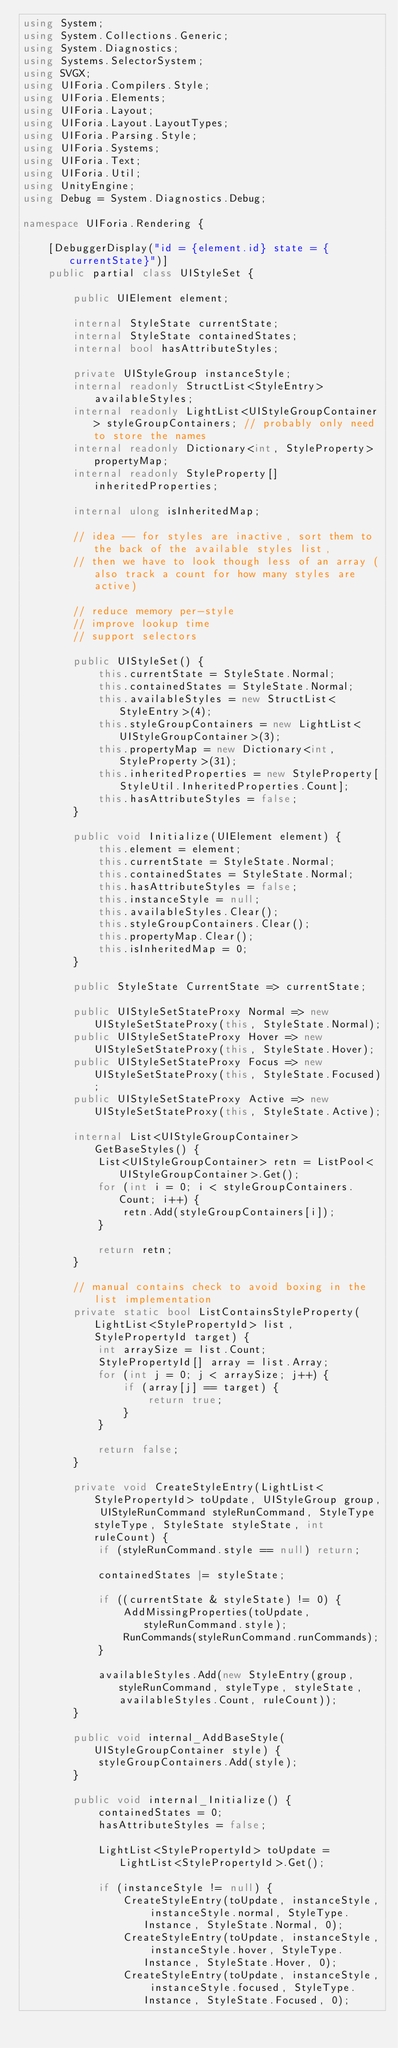<code> <loc_0><loc_0><loc_500><loc_500><_C#_>using System;
using System.Collections.Generic;
using System.Diagnostics;
using Systems.SelectorSystem;
using SVGX;
using UIForia.Compilers.Style;
using UIForia.Elements;
using UIForia.Layout;
using UIForia.Layout.LayoutTypes;
using UIForia.Parsing.Style;
using UIForia.Systems;
using UIForia.Text;
using UIForia.Util;
using UnityEngine;
using Debug = System.Diagnostics.Debug;

namespace UIForia.Rendering {

    [DebuggerDisplay("id = {element.id} state = {currentState}")]
    public partial class UIStyleSet {

        public UIElement element;

        internal StyleState currentState;
        internal StyleState containedStates;
        internal bool hasAttributeStyles;

        private UIStyleGroup instanceStyle;
        internal readonly StructList<StyleEntry> availableStyles;
        internal readonly LightList<UIStyleGroupContainer> styleGroupContainers; // probably only need to store the names
        internal readonly Dictionary<int, StyleProperty> propertyMap;
        internal readonly StyleProperty[] inheritedProperties;

        internal ulong isInheritedMap;

        // idea -- for styles are inactive, sort them to the back of the available styles list,
        // then we have to look though less of an array (also track a count for how many styles are active)

        // reduce memory per-style
        // improve lookup time
        // support selectors

        public UIStyleSet() {
            this.currentState = StyleState.Normal;
            this.containedStates = StyleState.Normal;
            this.availableStyles = new StructList<StyleEntry>(4);
            this.styleGroupContainers = new LightList<UIStyleGroupContainer>(3);
            this.propertyMap = new Dictionary<int, StyleProperty>(31);
            this.inheritedProperties = new StyleProperty[StyleUtil.InheritedProperties.Count];
            this.hasAttributeStyles = false;
        }

        public void Initialize(UIElement element) {
            this.element = element;
            this.currentState = StyleState.Normal;
            this.containedStates = StyleState.Normal;
            this.hasAttributeStyles = false;
            this.instanceStyle = null;
            this.availableStyles.Clear();
            this.styleGroupContainers.Clear();
            this.propertyMap.Clear();
            this.isInheritedMap = 0;
        }
        
        public StyleState CurrentState => currentState;

        public UIStyleSetStateProxy Normal => new UIStyleSetStateProxy(this, StyleState.Normal);
        public UIStyleSetStateProxy Hover => new UIStyleSetStateProxy(this, StyleState.Hover);
        public UIStyleSetStateProxy Focus => new UIStyleSetStateProxy(this, StyleState.Focused);
        public UIStyleSetStateProxy Active => new UIStyleSetStateProxy(this, StyleState.Active);

        internal List<UIStyleGroupContainer> GetBaseStyles() {
            List<UIStyleGroupContainer> retn = ListPool<UIStyleGroupContainer>.Get();
            for (int i = 0; i < styleGroupContainers.Count; i++) {
                retn.Add(styleGroupContainers[i]);
            }

            return retn;
        }

        // manual contains check to avoid boxing in the list implementation
        private static bool ListContainsStyleProperty(LightList<StylePropertyId> list, StylePropertyId target) {
            int arraySize = list.Count;
            StylePropertyId[] array = list.Array;
            for (int j = 0; j < arraySize; j++) {
                if (array[j] == target) {
                    return true;
                }
            }

            return false;
        }

        private void CreateStyleEntry(LightList<StylePropertyId> toUpdate, UIStyleGroup group, UIStyleRunCommand styleRunCommand, StyleType styleType, StyleState styleState, int ruleCount) {
            if (styleRunCommand.style == null) return;

            containedStates |= styleState;

            if ((currentState & styleState) != 0) {
                AddMissingProperties(toUpdate, styleRunCommand.style);
                RunCommands(styleRunCommand.runCommands);
            }

            availableStyles.Add(new StyleEntry(group, styleRunCommand, styleType, styleState, availableStyles.Count, ruleCount));
        }

        public void internal_AddBaseStyle(UIStyleGroupContainer style) {
            styleGroupContainers.Add(style);
        }

        public void internal_Initialize() {
            containedStates = 0;
            hasAttributeStyles = false;

            LightList<StylePropertyId> toUpdate = LightList<StylePropertyId>.Get();

            if (instanceStyle != null) {
                CreateStyleEntry(toUpdate, instanceStyle, instanceStyle.normal, StyleType.Instance, StyleState.Normal, 0);
                CreateStyleEntry(toUpdate, instanceStyle, instanceStyle.hover, StyleType.Instance, StyleState.Hover, 0);
                CreateStyleEntry(toUpdate, instanceStyle, instanceStyle.focused, StyleType.Instance, StyleState.Focused, 0);</code> 